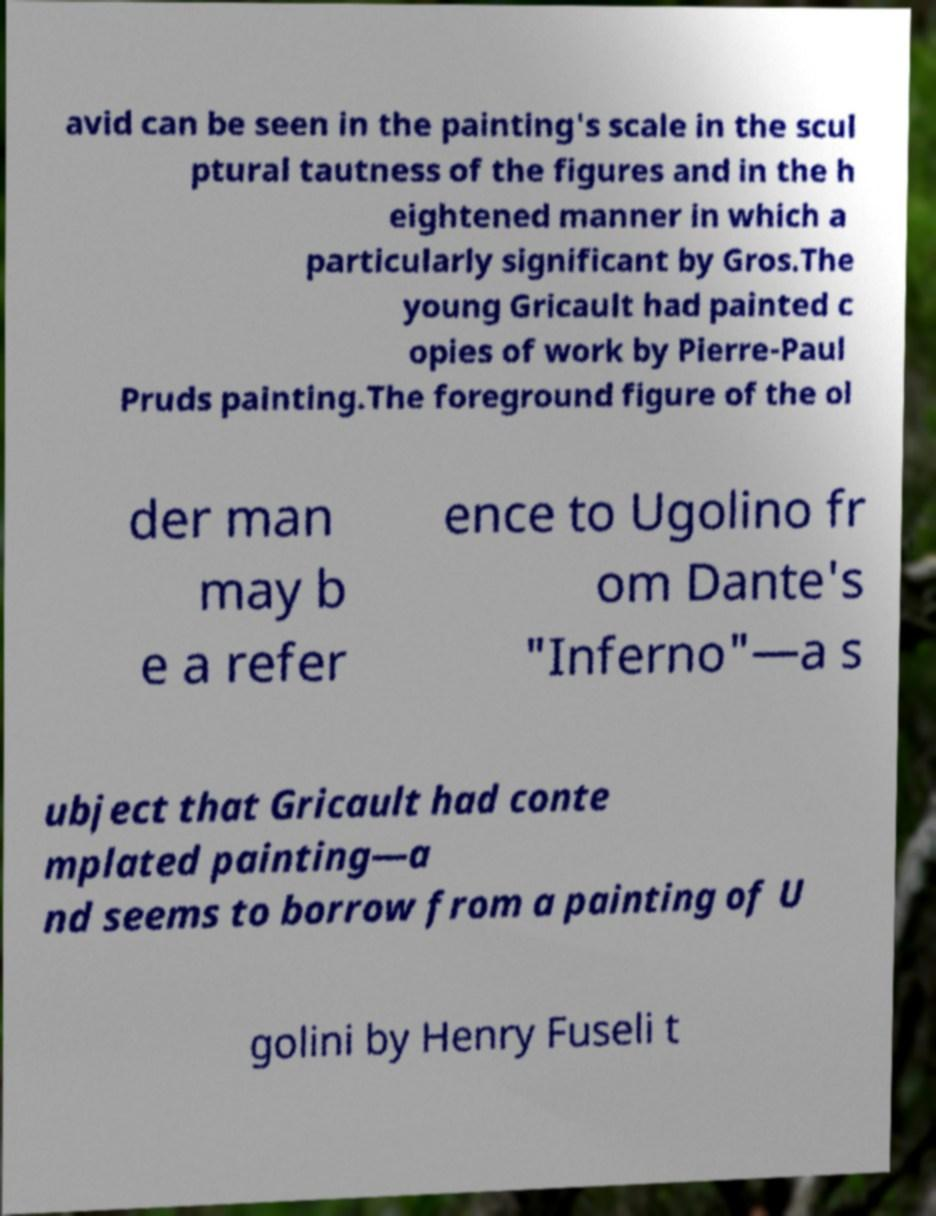Could you extract and type out the text from this image? avid can be seen in the painting's scale in the scul ptural tautness of the figures and in the h eightened manner in which a particularly significant by Gros.The young Gricault had painted c opies of work by Pierre-Paul Pruds painting.The foreground figure of the ol der man may b e a refer ence to Ugolino fr om Dante's "Inferno"—a s ubject that Gricault had conte mplated painting—a nd seems to borrow from a painting of U golini by Henry Fuseli t 